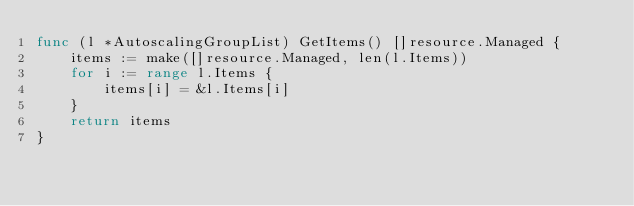<code> <loc_0><loc_0><loc_500><loc_500><_Go_>func (l *AutoscalingGroupList) GetItems() []resource.Managed {
	items := make([]resource.Managed, len(l.Items))
	for i := range l.Items {
		items[i] = &l.Items[i]
	}
	return items
}
</code> 